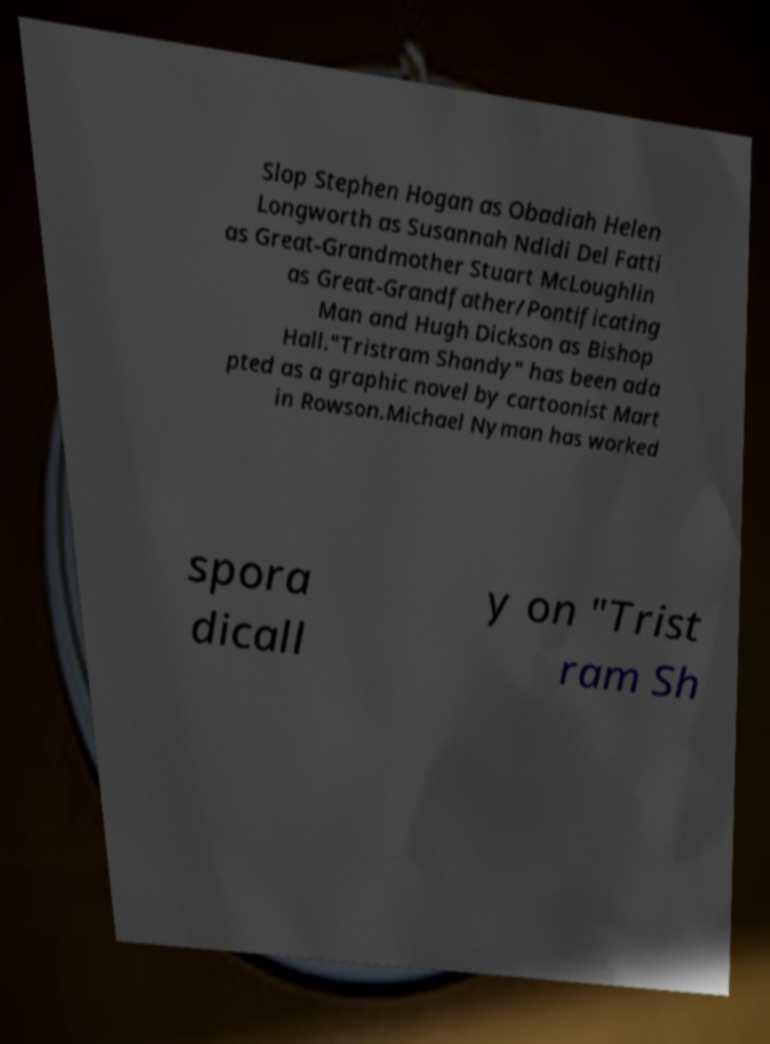I need the written content from this picture converted into text. Can you do that? Slop Stephen Hogan as Obadiah Helen Longworth as Susannah Ndidi Del Fatti as Great-Grandmother Stuart McLoughlin as Great-Grandfather/Pontificating Man and Hugh Dickson as Bishop Hall."Tristram Shandy" has been ada pted as a graphic novel by cartoonist Mart in Rowson.Michael Nyman has worked spora dicall y on "Trist ram Sh 